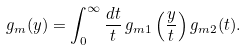Convert formula to latex. <formula><loc_0><loc_0><loc_500><loc_500>g _ { m } ( y ) = \int _ { 0 } ^ { \infty } \frac { d t } { t } \, g _ { m 1 } \left ( \frac { y } { t } \right ) g _ { m 2 } ( t ) .</formula> 